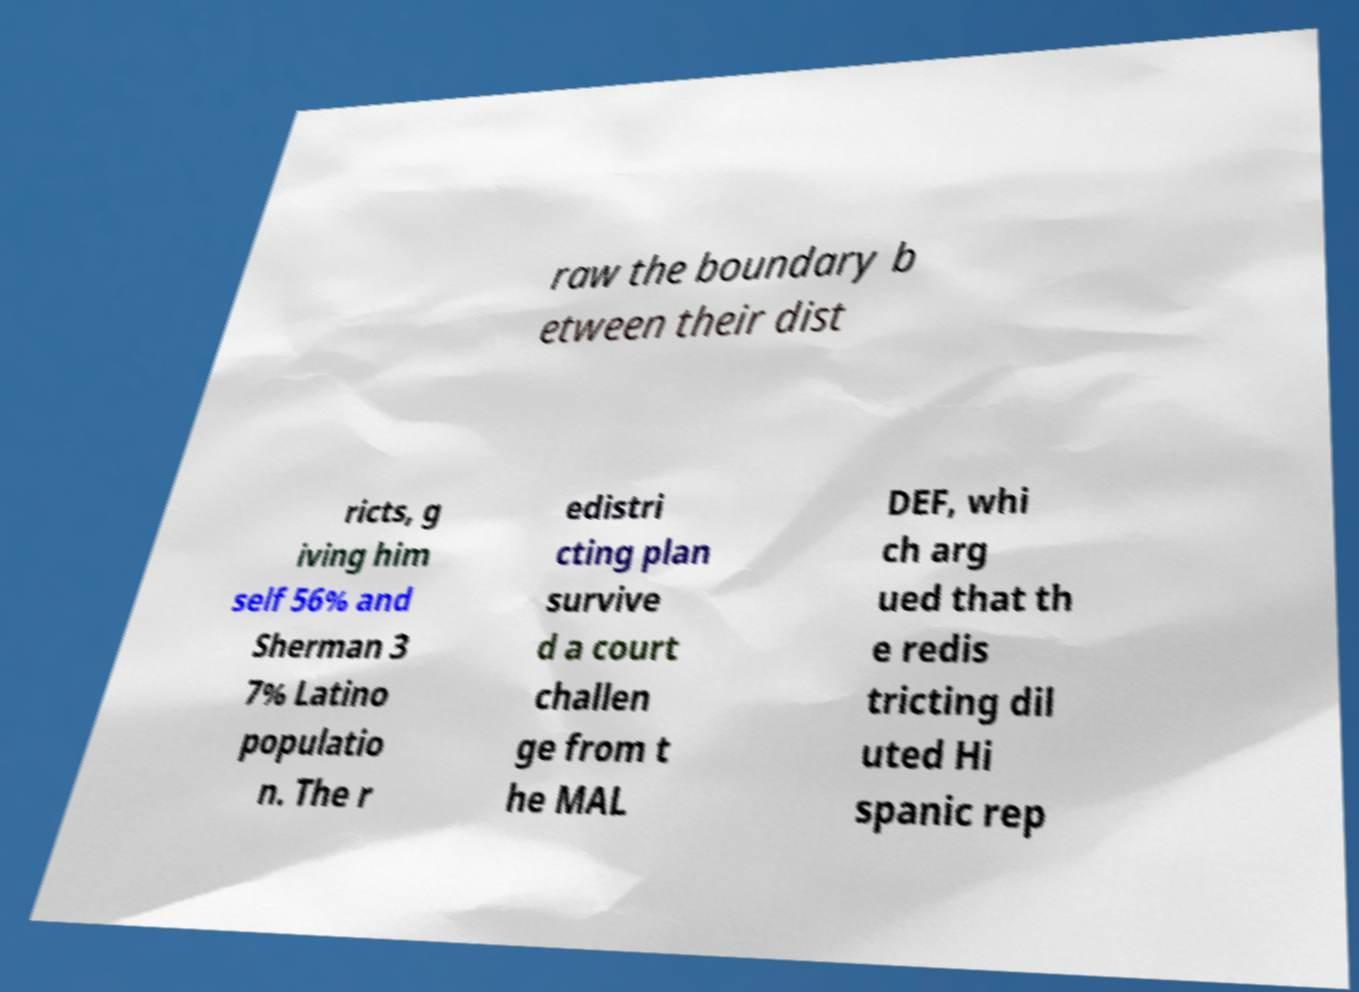What messages or text are displayed in this image? I need them in a readable, typed format. raw the boundary b etween their dist ricts, g iving him self 56% and Sherman 3 7% Latino populatio n. The r edistri cting plan survive d a court challen ge from t he MAL DEF, whi ch arg ued that th e redis tricting dil uted Hi spanic rep 